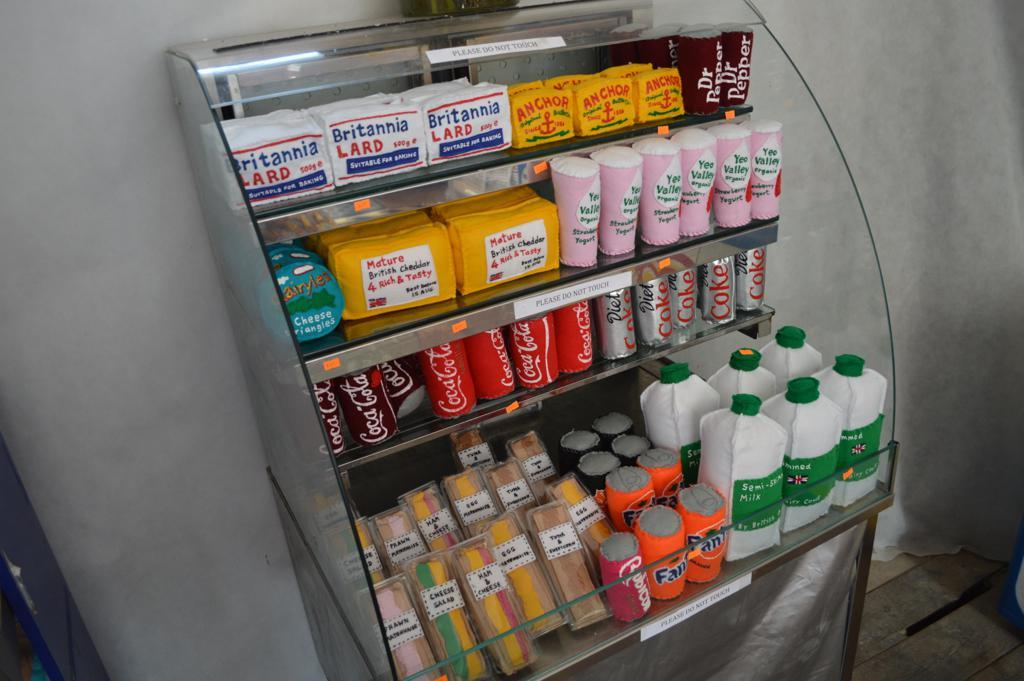<image>
Offer a succinct explanation of the picture presented. a display of products that says to not touch it 